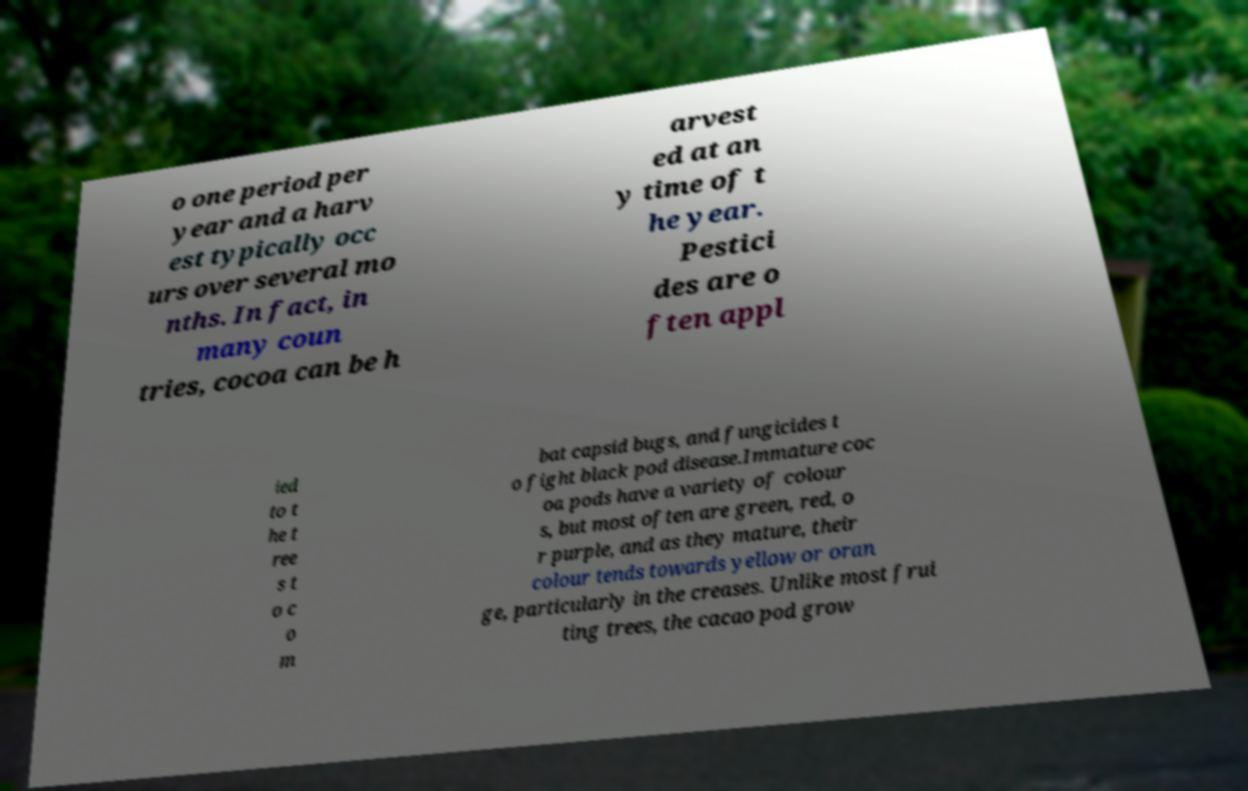Could you extract and type out the text from this image? o one period per year and a harv est typically occ urs over several mo nths. In fact, in many coun tries, cocoa can be h arvest ed at an y time of t he year. Pestici des are o ften appl ied to t he t ree s t o c o m bat capsid bugs, and fungicides t o fight black pod disease.Immature coc oa pods have a variety of colour s, but most often are green, red, o r purple, and as they mature, their colour tends towards yellow or oran ge, particularly in the creases. Unlike most frui ting trees, the cacao pod grow 